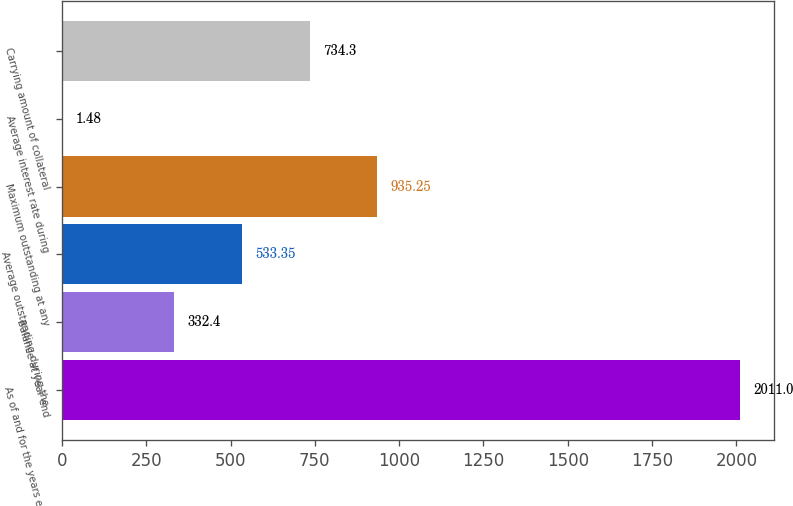Convert chart to OTSL. <chart><loc_0><loc_0><loc_500><loc_500><bar_chart><fcel>As of and for the years ended<fcel>Balance at year end<fcel>Average outstanding during the<fcel>Maximum outstanding at any<fcel>Average interest rate during<fcel>Carrying amount of collateral<nl><fcel>2011<fcel>332.4<fcel>533.35<fcel>935.25<fcel>1.48<fcel>734.3<nl></chart> 